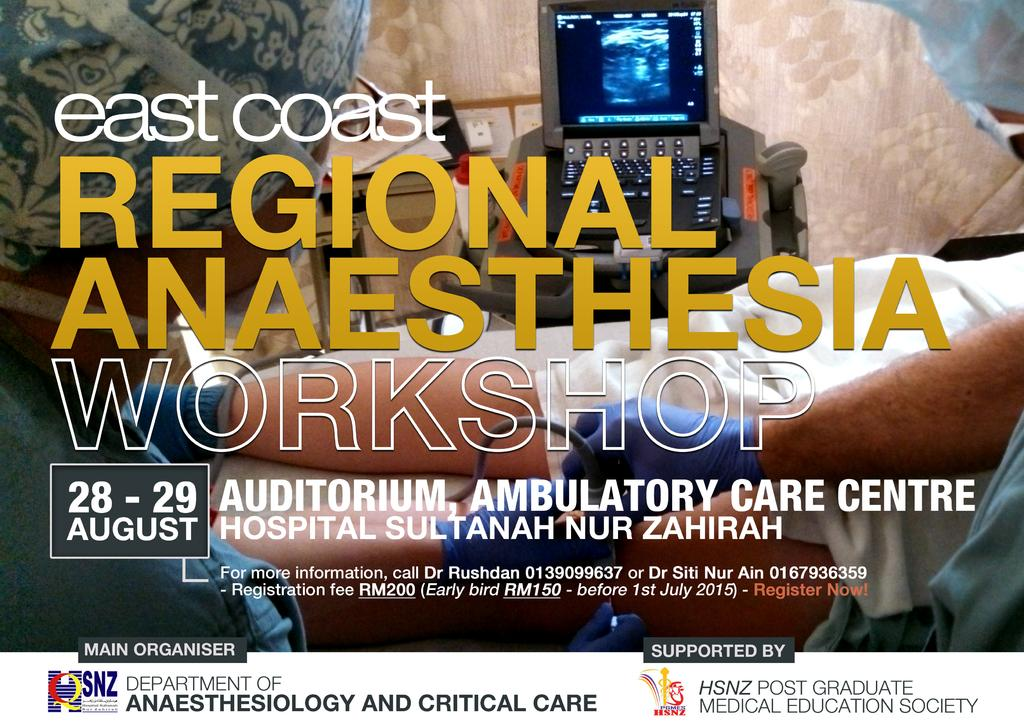<image>
Offer a succinct explanation of the picture presented. Sign for east coast regional anaesthesia workshop taking place in August 